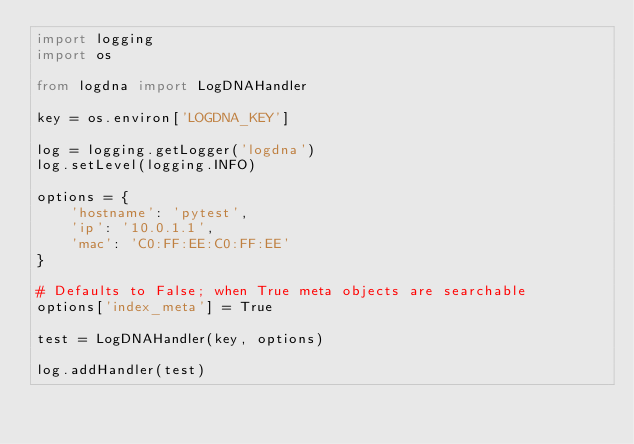<code> <loc_0><loc_0><loc_500><loc_500><_Python_>import logging
import os

from logdna import LogDNAHandler

key = os.environ['LOGDNA_KEY']

log = logging.getLogger('logdna')
log.setLevel(logging.INFO)

options = {
    'hostname': 'pytest',
    'ip': '10.0.1.1',
    'mac': 'C0:FF:EE:C0:FF:EE'
}

# Defaults to False; when True meta objects are searchable
options['index_meta'] = True

test = LogDNAHandler(key, options)

log.addHandler(test)
</code> 